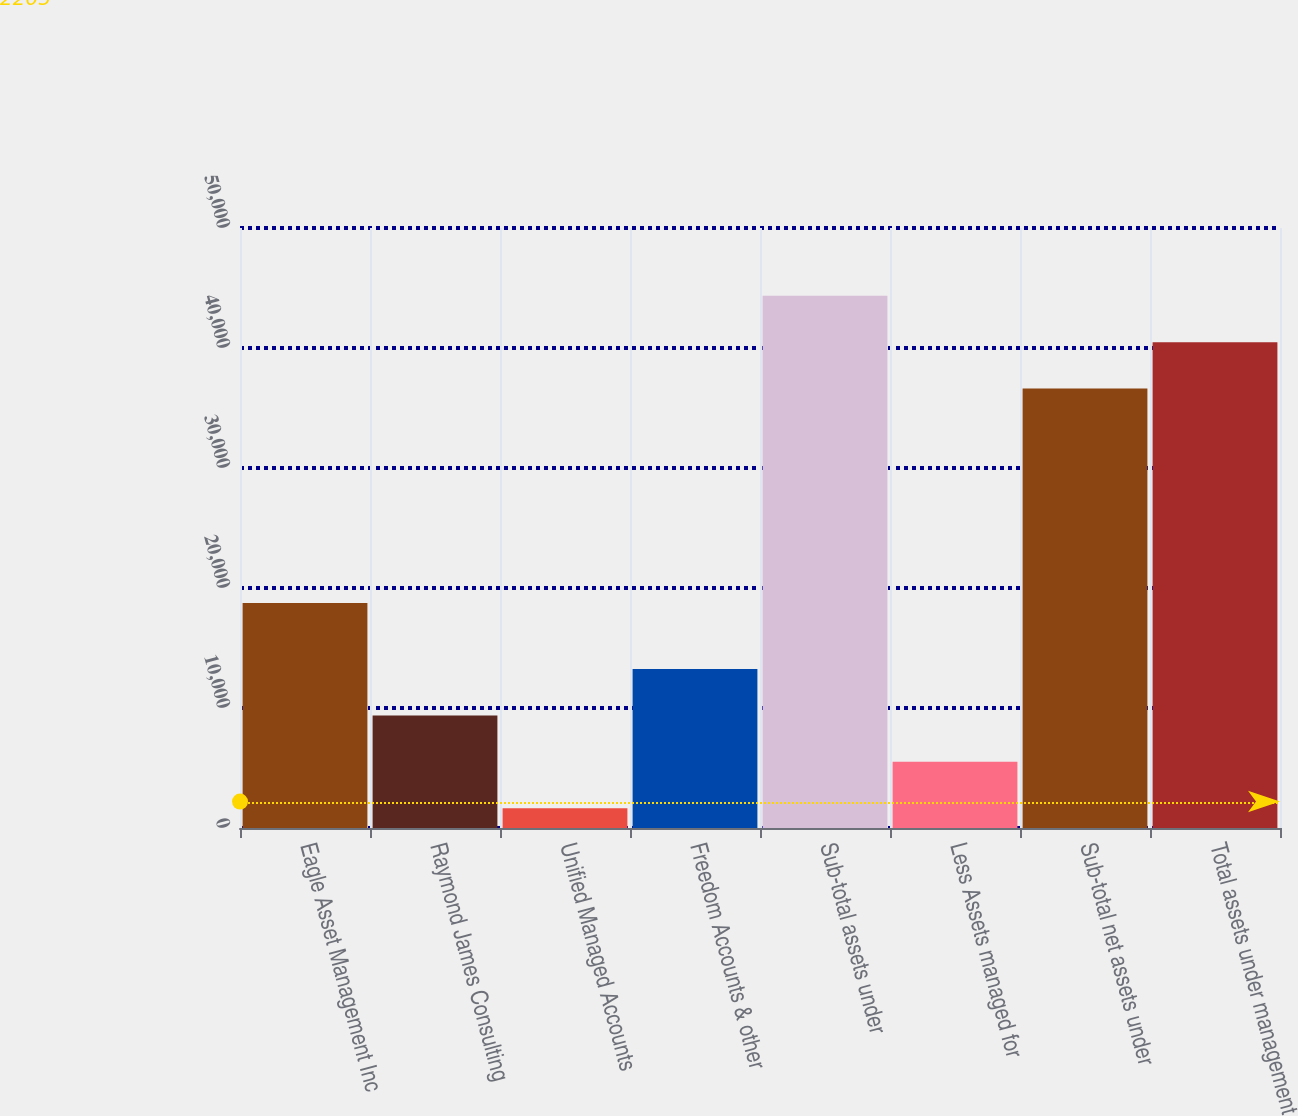Convert chart. <chart><loc_0><loc_0><loc_500><loc_500><bar_chart><fcel>Eagle Asset Management Inc<fcel>Raymond James Consulting<fcel>Unified Managed Accounts<fcel>Freedom Accounts & other<fcel>Sub-total assets under<fcel>Less Assets managed for<fcel>Sub-total net assets under<fcel>Total assets under management<nl><fcel>18745<fcel>9380.6<fcel>1653<fcel>13244.4<fcel>44350.6<fcel>5516.8<fcel>36623<fcel>40486.8<nl></chart> 